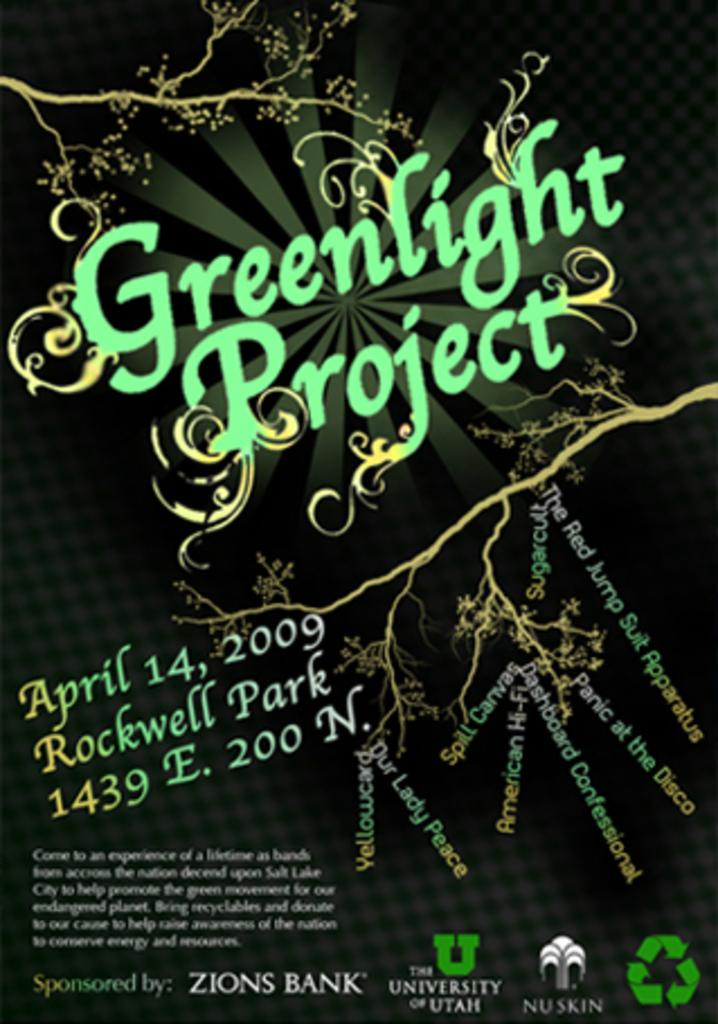What is present in the picture? There is a poster in the picture. Can you describe the poster? The poster has a design and texts. How many family members are sitting on the chairs in the picture? There are no family members or chairs present in the image; it only features a poster with a design and texts. What is the occasion for the birthday celebration in the picture? There is no birthday celebration or any reference to a birthday in the image. 